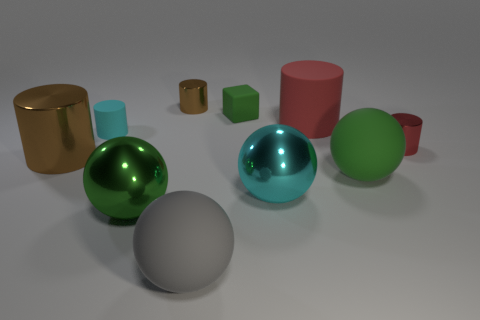Do the big cylinder on the right side of the tiny cyan object and the small brown thing have the same material?
Give a very brief answer. No. What is the large object that is behind the red shiny cylinder made of?
Your answer should be very brief. Rubber. There is a rubber sphere behind the big green thing that is in front of the big cyan metal thing; what is its size?
Provide a short and direct response. Large. What number of brown rubber objects are the same size as the red shiny cylinder?
Give a very brief answer. 0. There is a large ball to the left of the small brown thing; does it have the same color as the tiny cylinder on the right side of the tiny cube?
Provide a short and direct response. No. There is a large red object; are there any tiny shiny objects to the right of it?
Offer a very short reply. Yes. What color is the metal cylinder that is both on the left side of the large gray matte object and in front of the tiny green cube?
Keep it short and to the point. Brown. Is there a tiny metallic thing of the same color as the rubber block?
Offer a terse response. No. Are the big green sphere that is to the left of the gray matte sphere and the small cylinder behind the cyan matte cylinder made of the same material?
Keep it short and to the point. Yes. There is a cyan object on the right side of the gray object; what size is it?
Keep it short and to the point. Large. 